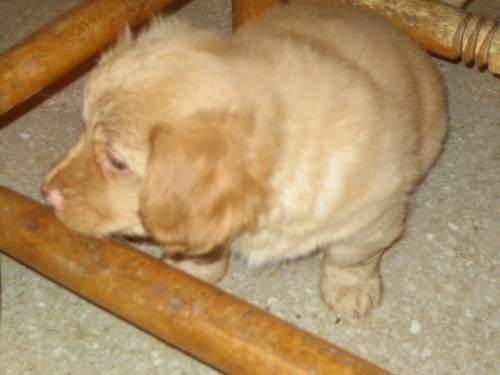Are the texture details of the main subject lost? Yes, it appears that the texture details of the puppy in the image are somewhat lost due to either the image's low resolution or poor lighting conditions. This makes it difficult to see the finer details of the puppy's fur. 